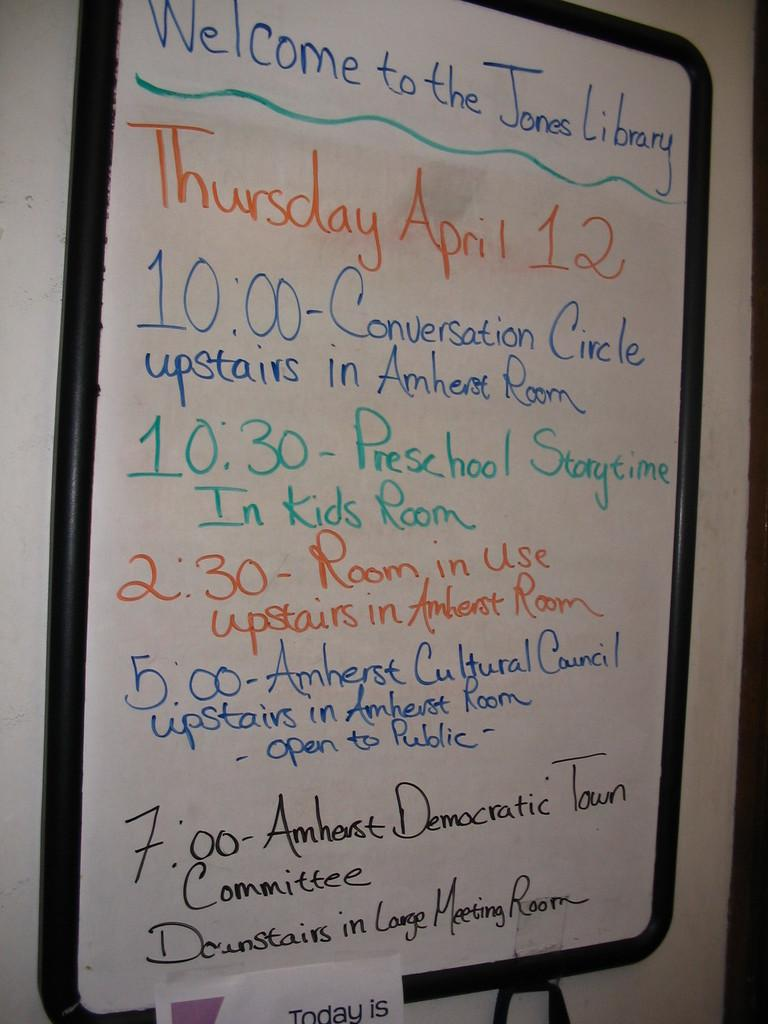Provide a one-sentence caption for the provided image. A whiteboard welcoming people to the Jones Library also showing the the times of different events and times. 